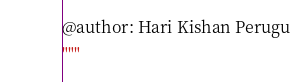<code> <loc_0><loc_0><loc_500><loc_500><_Python_>@author: Hari Kishan Perugu
"""

</code> 